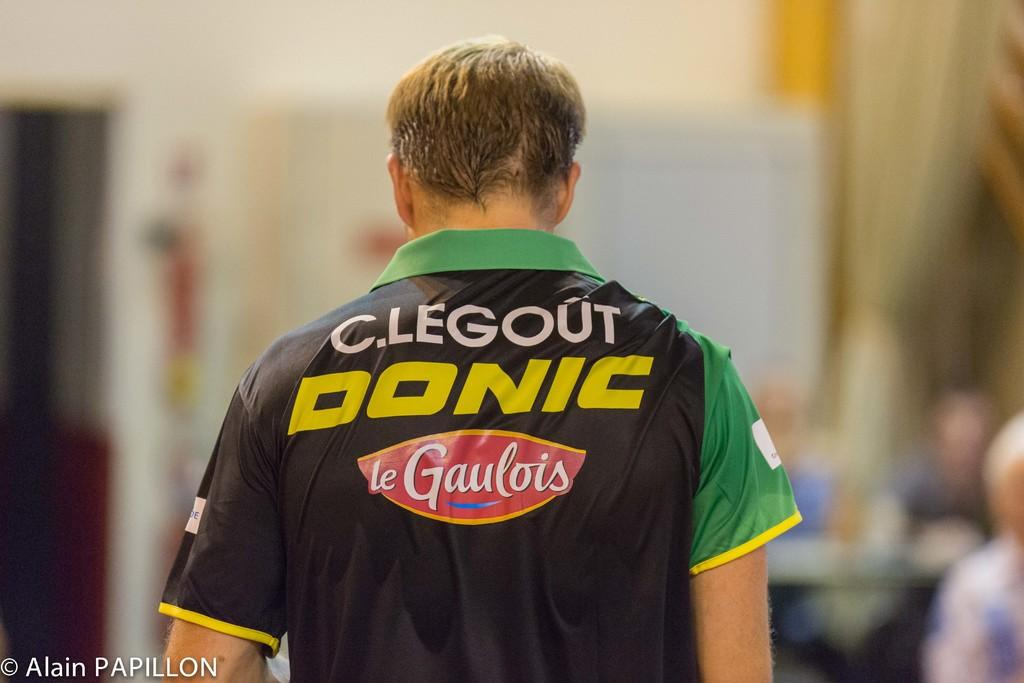<image>
Write a terse but informative summary of the picture. A man wears a polo shirt with sponsors such as Donic and Le Gaulois on it. 